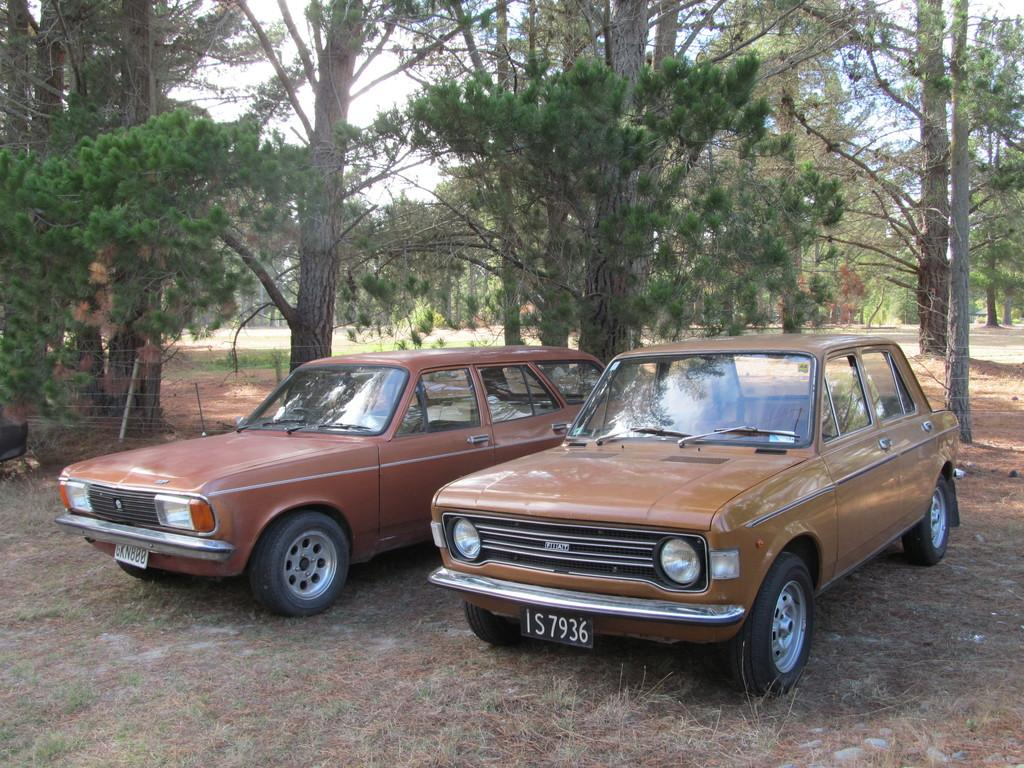Where was the picture taken? The picture was taken outside. What can be seen in the center of the image? There are two cars parked in the center of the image. How are the cars positioned in the image? The cars are parked on the ground. What can be seen in the background of the image? There is a sky, trees, grass, and other unspecified objects visible in the background of the image. What type of dirt can be seen on the cars in the image? There is no dirt visible on the cars in the image. How does the net help the cars in the image? There is no net present in the image, so it cannot help the cars. 